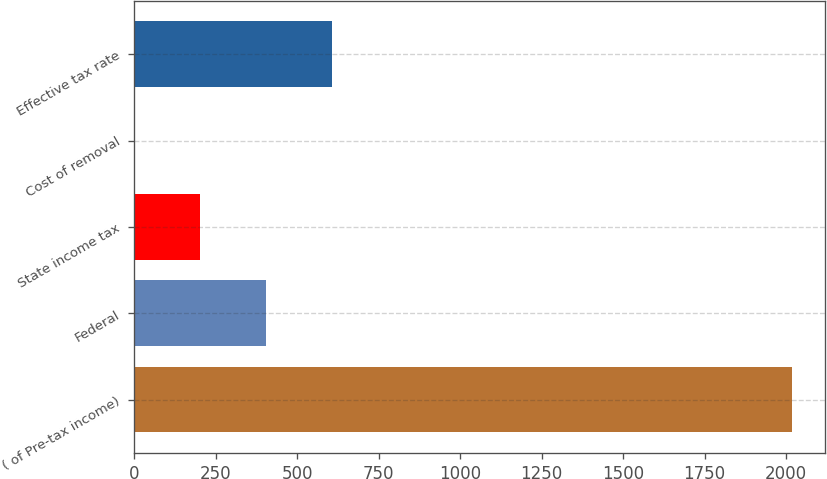Convert chart. <chart><loc_0><loc_0><loc_500><loc_500><bar_chart><fcel>( of Pre-tax income)<fcel>Federal<fcel>State income tax<fcel>Cost of removal<fcel>Effective tax rate<nl><fcel>2018<fcel>404.4<fcel>202.7<fcel>1<fcel>606.1<nl></chart> 